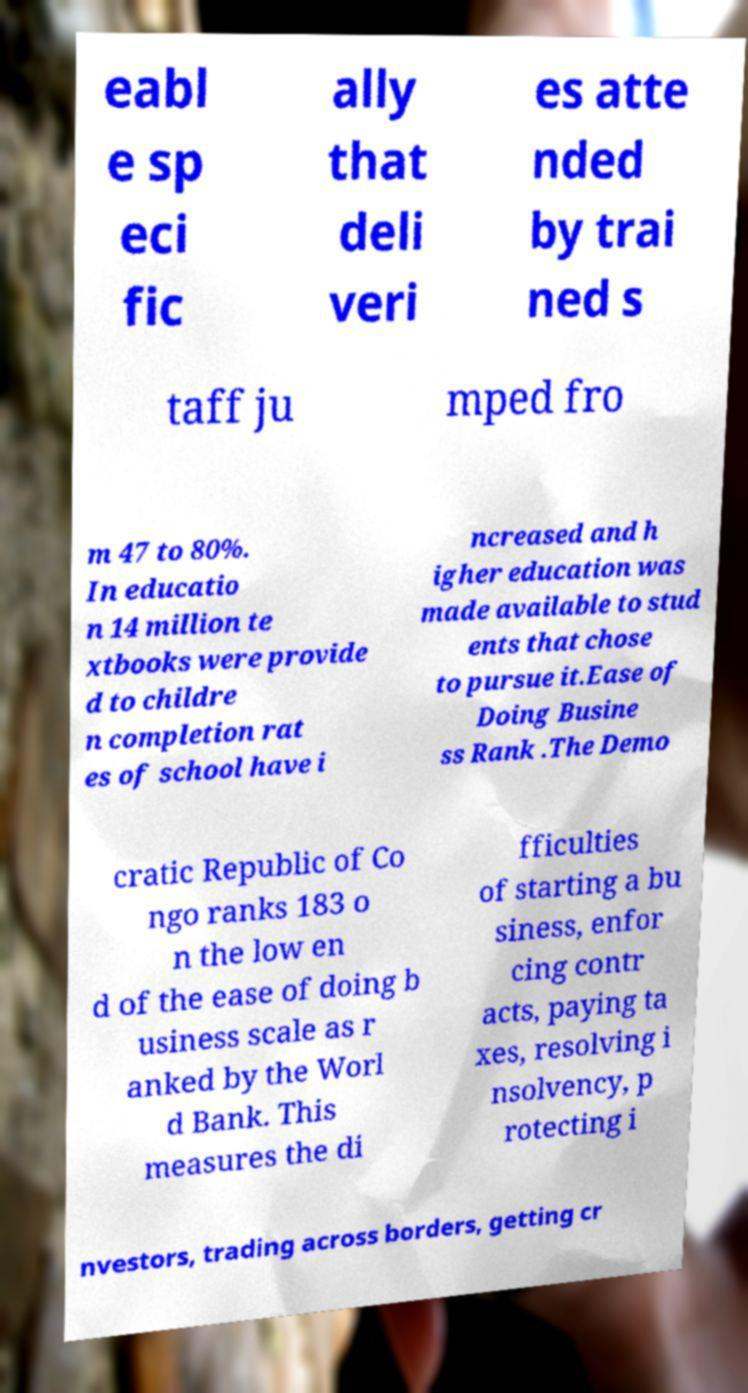I need the written content from this picture converted into text. Can you do that? eabl e sp eci fic ally that deli veri es atte nded by trai ned s taff ju mped fro m 47 to 80%. In educatio n 14 million te xtbooks were provide d to childre n completion rat es of school have i ncreased and h igher education was made available to stud ents that chose to pursue it.Ease of Doing Busine ss Rank .The Demo cratic Republic of Co ngo ranks 183 o n the low en d of the ease of doing b usiness scale as r anked by the Worl d Bank. This measures the di fficulties of starting a bu siness, enfor cing contr acts, paying ta xes, resolving i nsolvency, p rotecting i nvestors, trading across borders, getting cr 